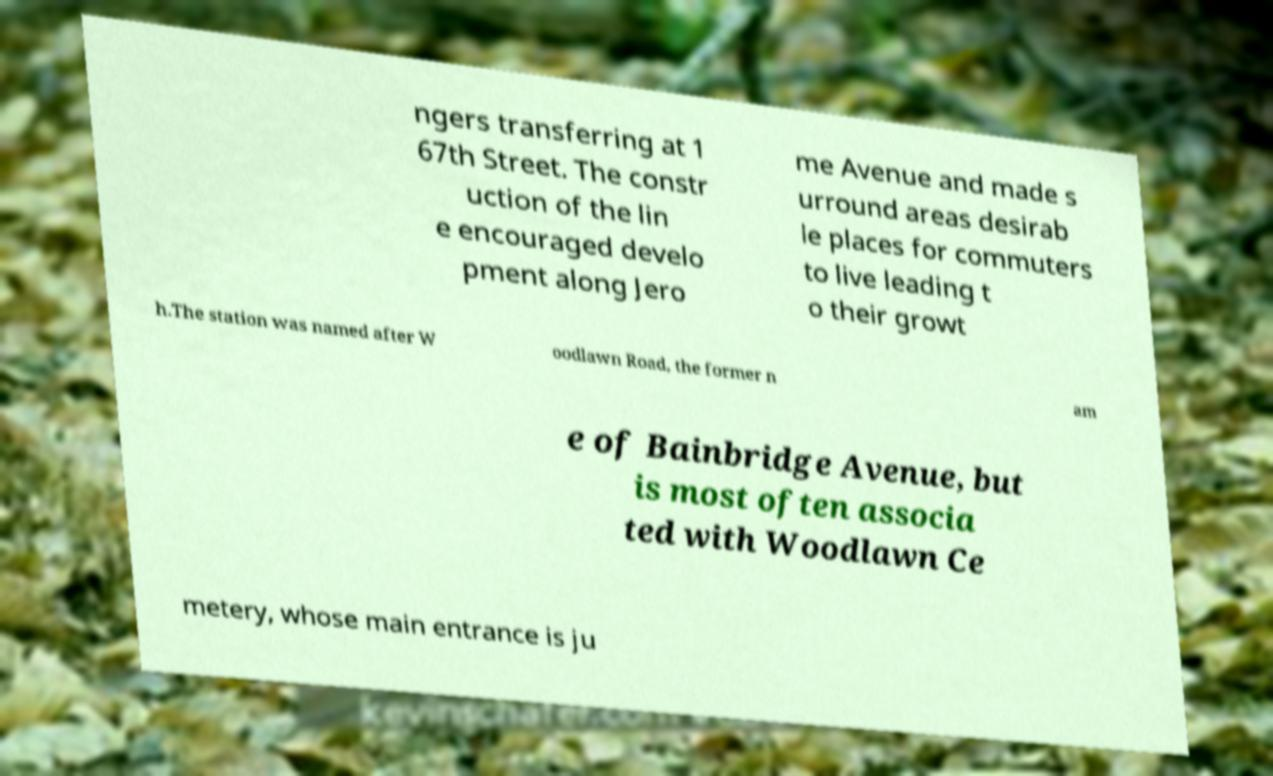Can you read and provide the text displayed in the image?This photo seems to have some interesting text. Can you extract and type it out for me? ngers transferring at 1 67th Street. The constr uction of the lin e encouraged develo pment along Jero me Avenue and made s urround areas desirab le places for commuters to live leading t o their growt h.The station was named after W oodlawn Road, the former n am e of Bainbridge Avenue, but is most often associa ted with Woodlawn Ce metery, whose main entrance is ju 